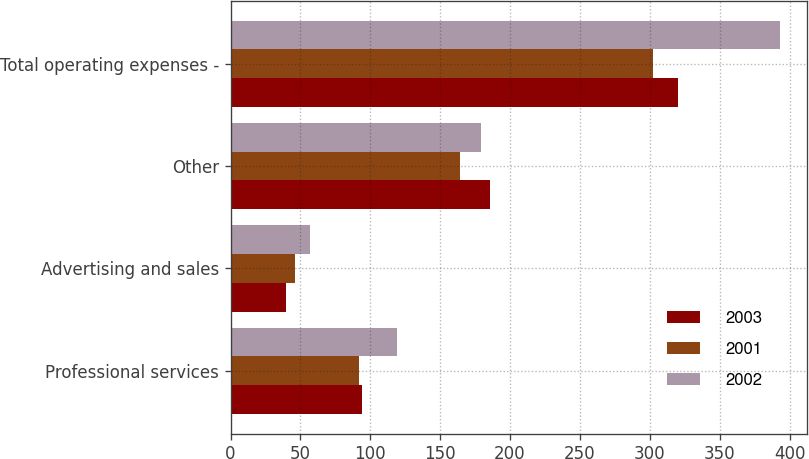Convert chart. <chart><loc_0><loc_0><loc_500><loc_500><stacked_bar_chart><ecel><fcel>Professional services<fcel>Advertising and sales<fcel>Other<fcel>Total operating expenses -<nl><fcel>2003<fcel>94<fcel>40<fcel>186<fcel>320<nl><fcel>2001<fcel>92<fcel>46<fcel>164<fcel>302<nl><fcel>2002<fcel>119<fcel>57<fcel>179<fcel>393<nl></chart> 